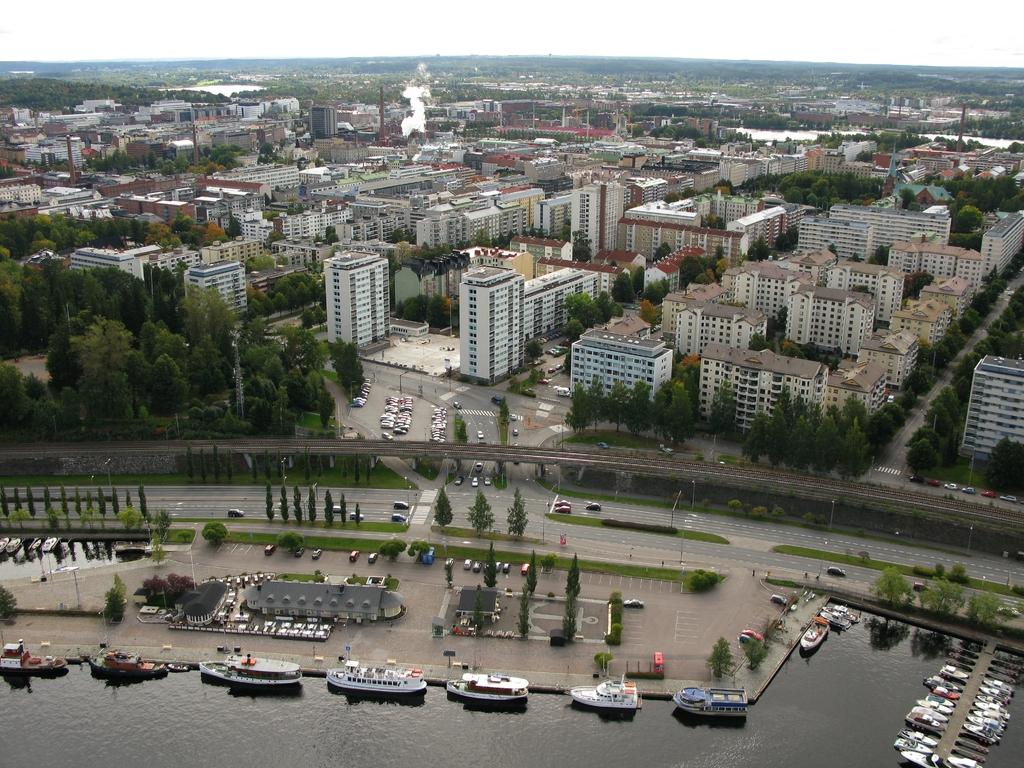What types of watercraft are in the image? There are ships and boats in the image. Are the ships and boats in contact with the water? Yes, the ships and boats are above the water. What else can be seen in the image besides watercraft? There are vehicles on the road, trees, buildings, poles, and smoke visible in the image. What is visible in the background of the image? The sky is visible in the image. What type of memory is being used by the potato in the image? There is no potato present in the image, and therefore no memory can be attributed to it. 